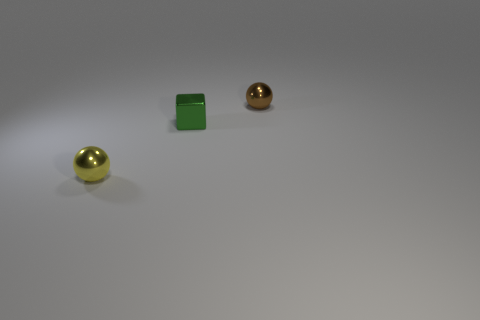What number of spheres are either small yellow metal objects or tiny brown shiny things?
Provide a short and direct response. 2. What shape is the object that is to the right of the yellow thing and in front of the brown thing?
Your response must be concise. Cube. What is the color of the block that is to the right of the metallic ball left of the ball that is on the right side of the yellow shiny sphere?
Your response must be concise. Green. Is the number of small brown spheres that are to the right of the tiny metallic block less than the number of yellow balls?
Provide a short and direct response. No. There is a brown object behind the small green metallic thing; is its shape the same as the small shiny object that is in front of the block?
Give a very brief answer. Yes. What number of objects are metal balls behind the green thing or big cyan metallic balls?
Give a very brief answer. 1. There is a small metallic cube on the right side of the sphere that is in front of the small brown object; are there any tiny green metallic cubes right of it?
Your answer should be compact. No. Is the number of metal blocks behind the tiny yellow ball less than the number of yellow objects left of the brown ball?
Make the answer very short. No. The block that is the same material as the yellow object is what color?
Provide a succinct answer. Green. There is a sphere that is behind the sphere on the left side of the tiny brown shiny object; what is its color?
Make the answer very short. Brown. 